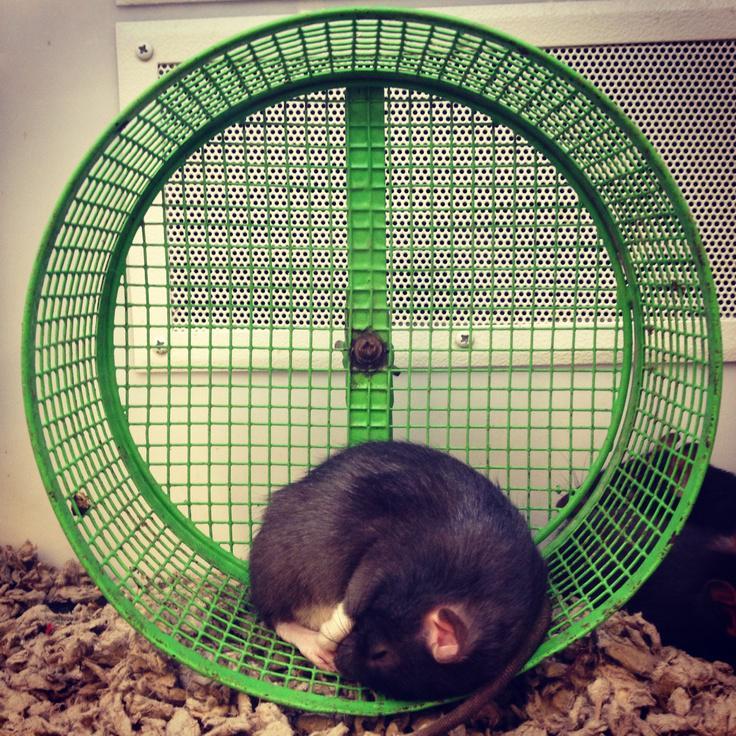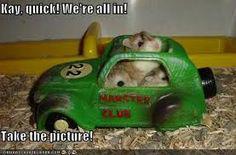The first image is the image on the left, the second image is the image on the right. Examine the images to the left and right. Is the description "Each image shows a hamster in a wheel, and one image shows three hamsters in a wheel with non-mesh green sides." accurate? Answer yes or no. No. The first image is the image on the left, the second image is the image on the right. For the images displayed, is the sentence "In one of the images, three hamsters are huddled together in a small space." factually correct? Answer yes or no. Yes. 